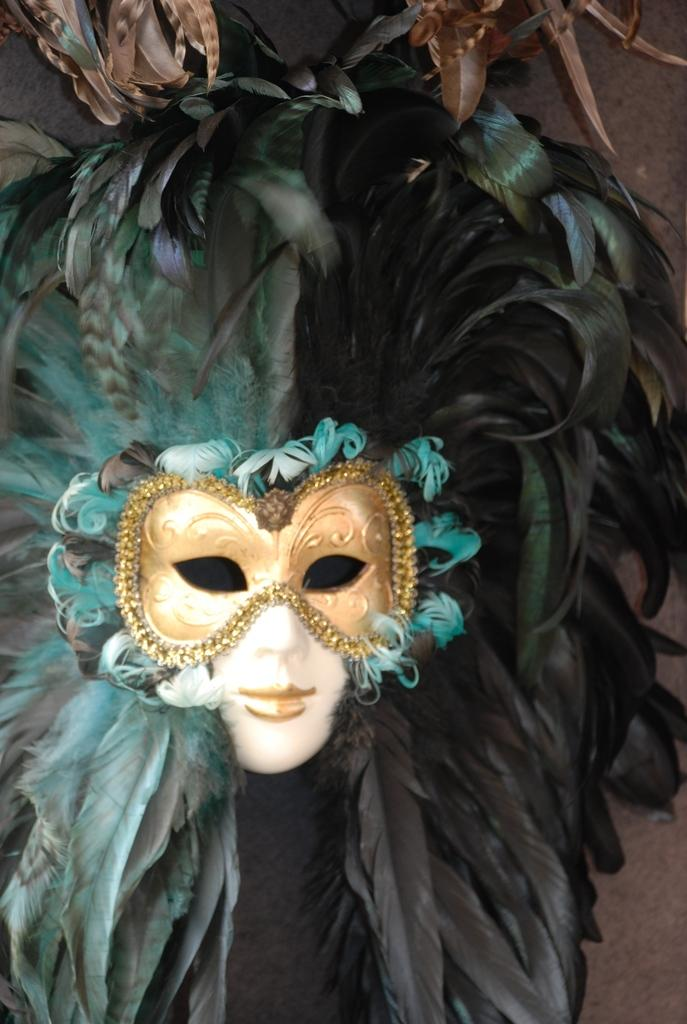Who or what is present in the image? There is a person in the image. What is the person wearing on their face? The person is wearing a mask. What is unique about the mask? There are feathers around the mask. What can be seen behind the person? There is a wall in the background of the image. What is visible beyond the wall? The sky is visible in the background of the image. Can you tell me how deep the river is in the image? There is no river present in the image; it features a person wearing a mask with feathers and a background with a wall and the sky. 